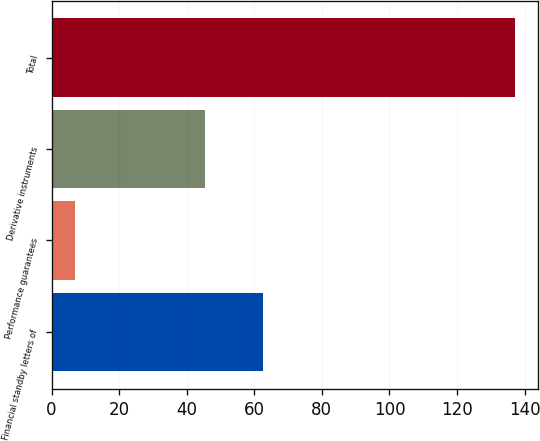Convert chart. <chart><loc_0><loc_0><loc_500><loc_500><bar_chart><fcel>Financial standby letters of<fcel>Performance guarantees<fcel>Derivative instruments<fcel>Total<nl><fcel>62.6<fcel>6.9<fcel>45.4<fcel>137.1<nl></chart> 